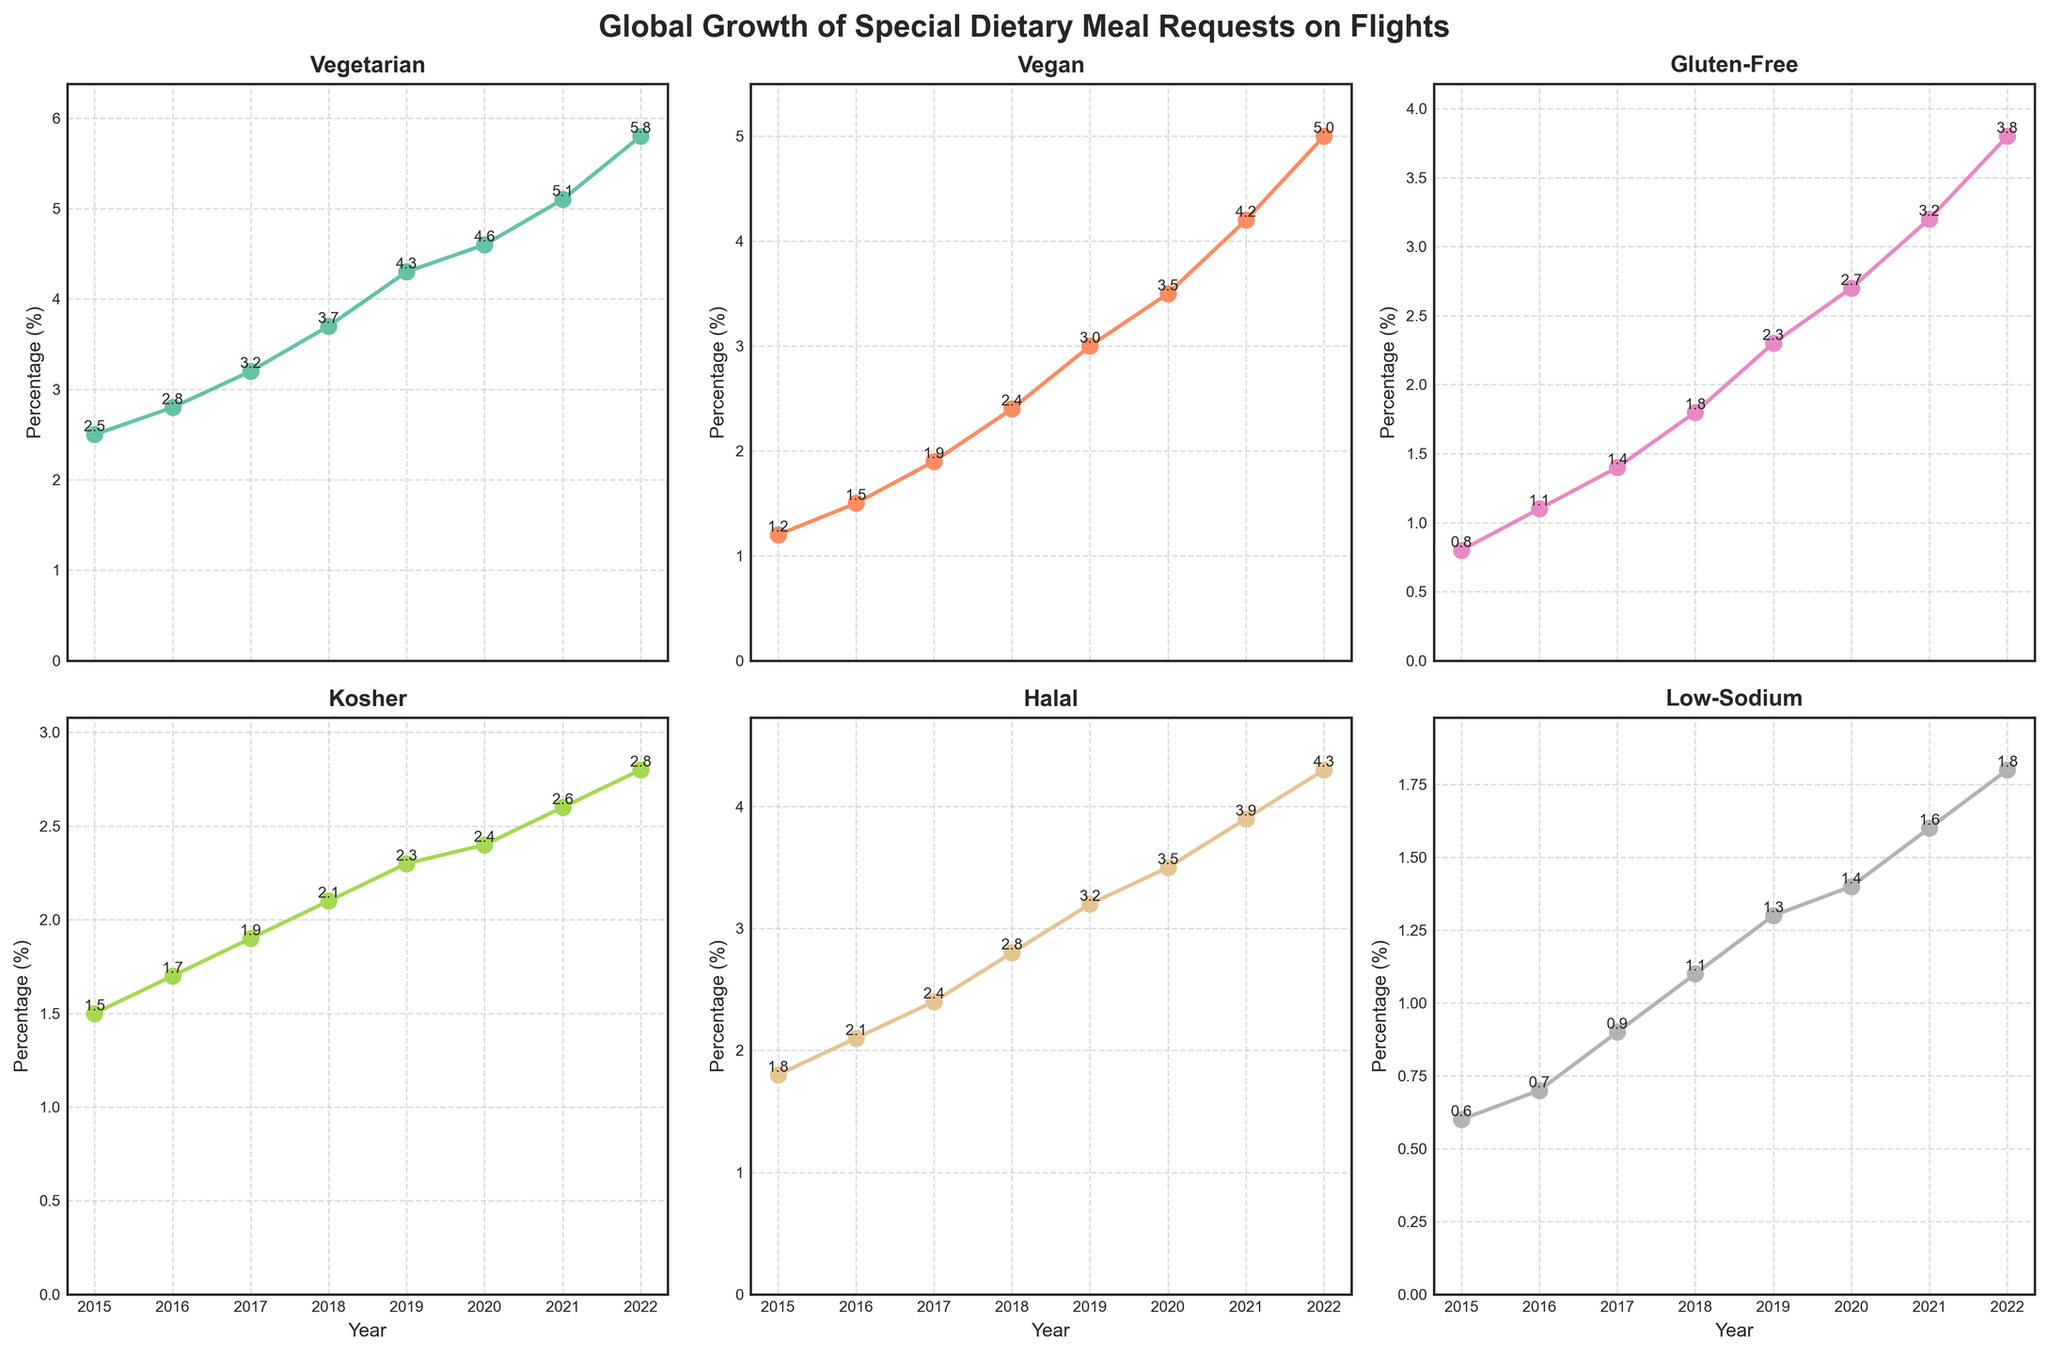what is the title of the figure? The figure has a title at the top that reads "Global Growth of Special Dietary Meal Requests on Flights."
Answer: Global Growth of Special Dietary Meal Requests on Flights Which special dietary meal had the highest percentage request in 2022? Observing the data points in 2022, the Vegetarian meal had the highest value, peaking at 5.8%.
Answer: Vegetarian How many cuisines are represented in the plot? There are 6 subplots, each representing a different cuisine: Vegetarian, Vegan, Gluten-Free, Kosher, Halal, and Low-Sodium.
Answer: 6 In which year did Vegan meal requests surpass Gluten-Free meal requests? Checking the plot, it is noticeable that in 2017 the Vegan (1.9%) meal requests surpassed the Gluten-Free (1.4%) meal requests, and this trend continued in subsequent years.
Answer: 2017 What was the percentage increase in Halal meal requests from 2015 to 2019? The percentage for Halal in 2015 was 1.8%, and in 2019 it was 3.2%. The increase is 3.2% - 1.8% = 1.4%.
Answer: 1.4% Compare the growth trends of Kosher and Low-Sodium meal requests between 2015 and 2022. Which had a steeper increase? From 2015 to 2022, Kosher increased from 1.5% to 2.8%, while Low-Sodium increased from 0.6% to 1.8%. Kosher's increase: 2.8% - 1.5% = 1.3%, Low-Sodium's increase: 1.8% - 0.6% = 1.2%. Kosher had a steeper increase.
Answer: Kosher Which year had the smallest percentage increase for Gluten-Free meals compared to the previous year? The smallest percentage increase for Gluten-Free meals occurred between 2016 and 2017, growing from 1.1% to 1.4%, an increase of 0.3%, which is less than in other years.
Answer: 2017 What is the average percentage request for Vegan meals from 2015 to 2022? To find the average, sum all the percentages for Vegan from 2015 to 2022: (1.2 + 1.5 + 1.9 + 2.4 + 3.0 + 3.5 + 4.2 + 5.0) = 22.7, and divide by the number of years (8). 22.7 / 8 = 2.8375.
Answer: 2.8 (rounded to one decimal place) Which special dietary meal had the most consistent growth trend from 2015 to 2022? By examining the plots, the Vegetarian meal shows a consistent and steady upward trend without any noticeable fluctuations over the years.
Answer: Vegetarian 